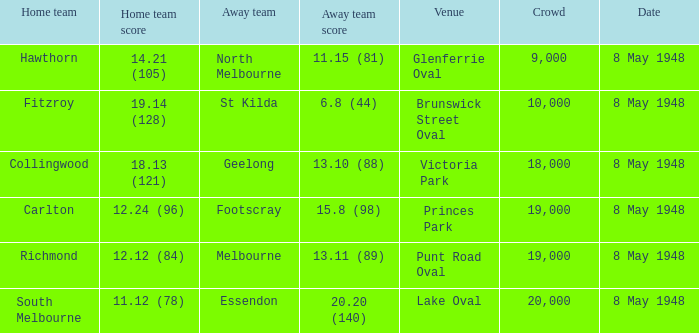Which visiting team has a home score of 14.21 (105)? North Melbourne. 